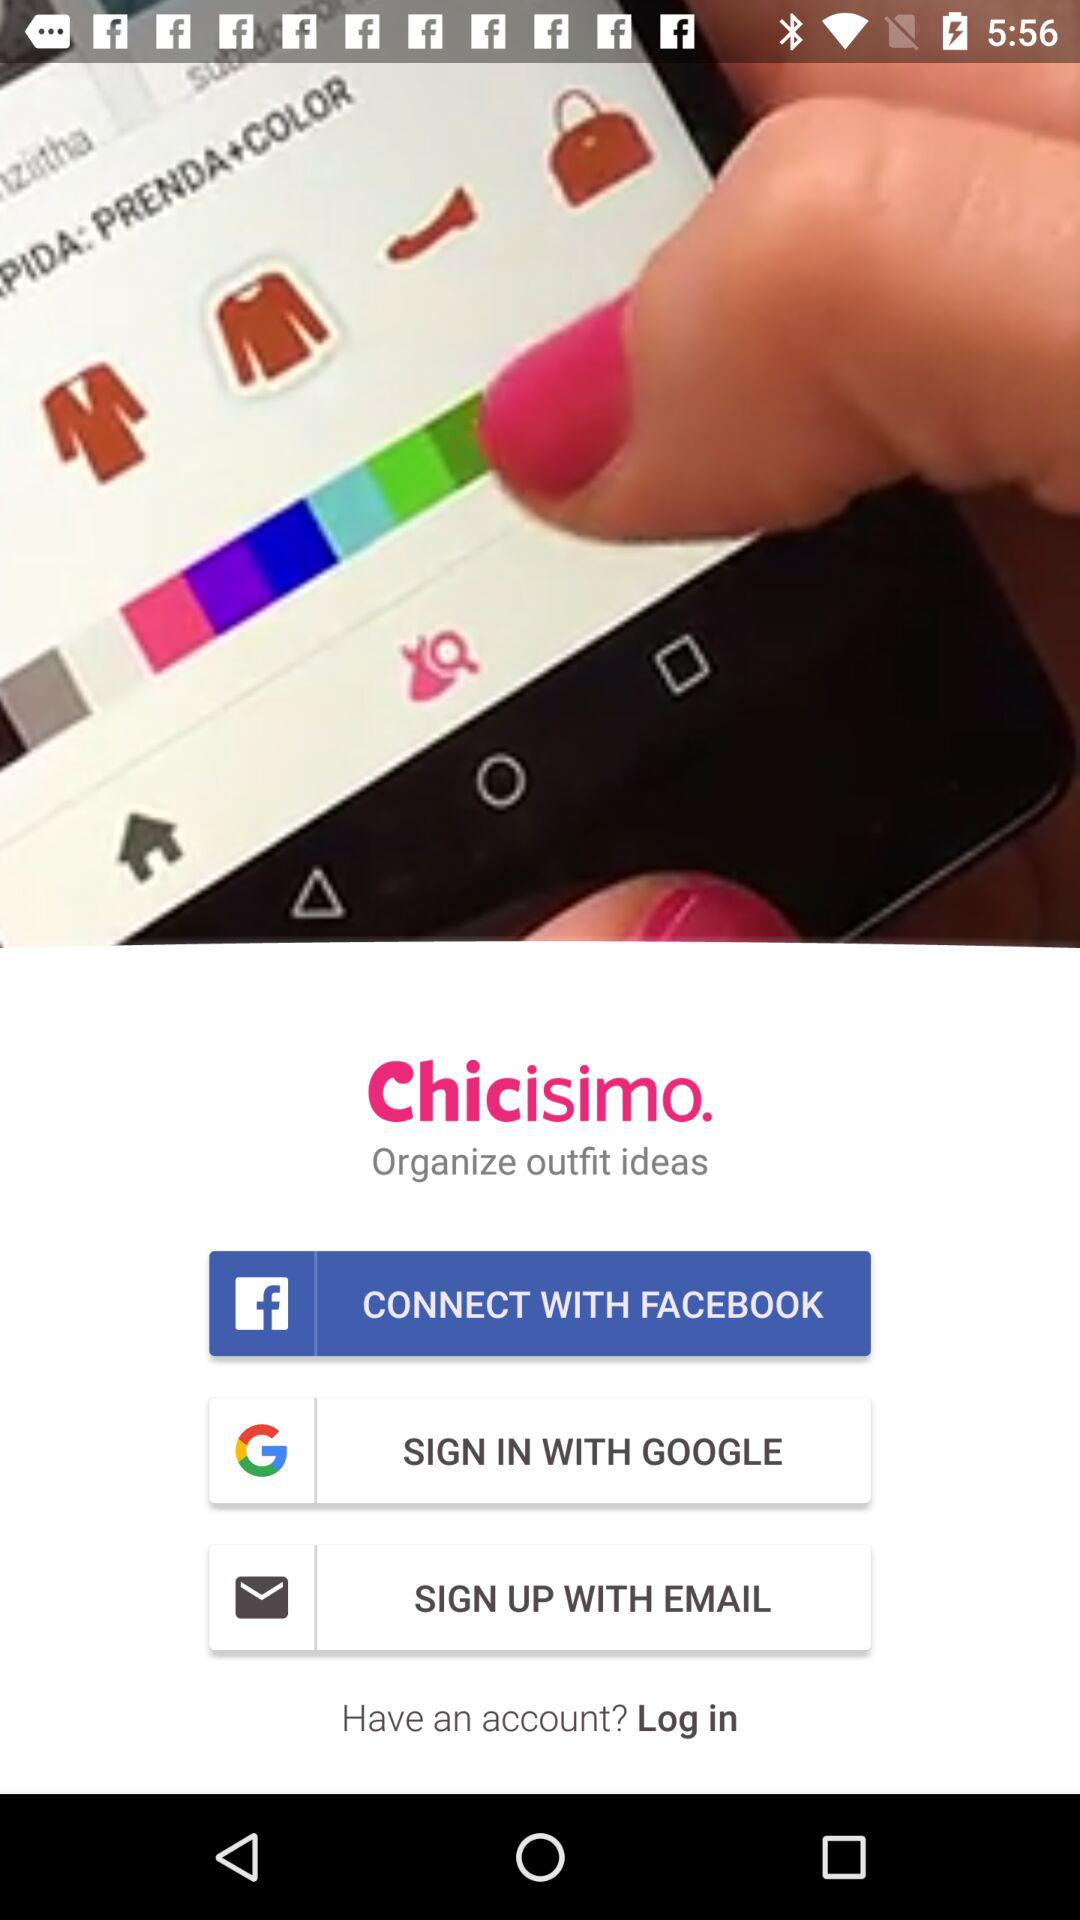How many sign in options are there?
Answer the question using a single word or phrase. 3 